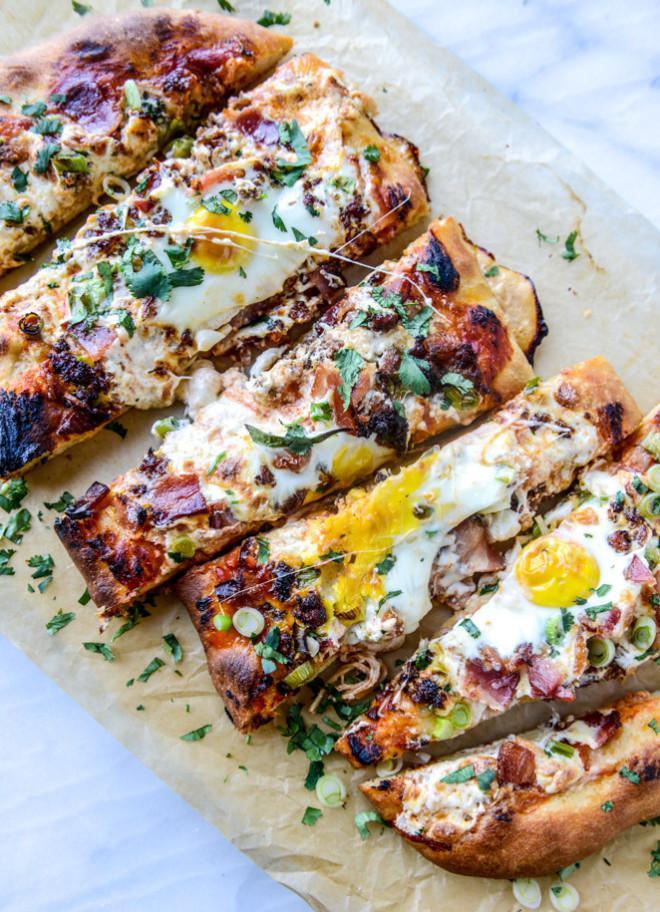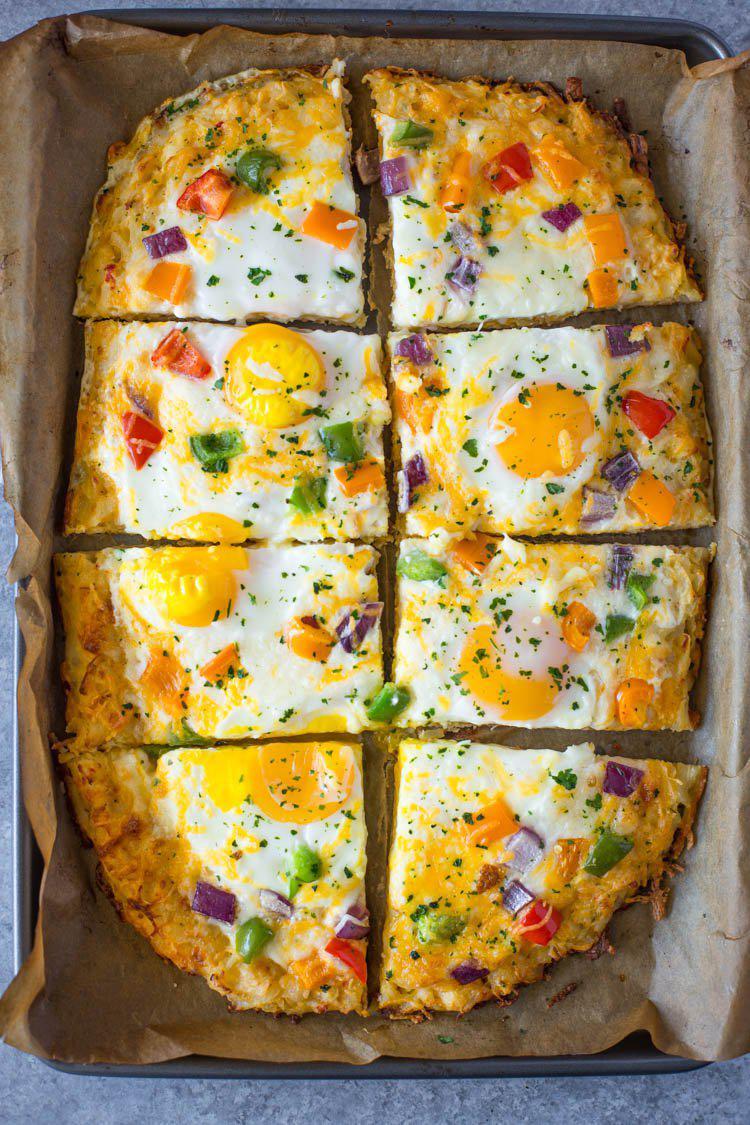The first image is the image on the left, the second image is the image on the right. Given the left and right images, does the statement "There are two round pizzas and at least one has avocados in the middle of the pizza." hold true? Answer yes or no. No. The first image is the image on the left, the second image is the image on the right. Examine the images to the left and right. Is the description "Both pizzas are cut into slices." accurate? Answer yes or no. Yes. 